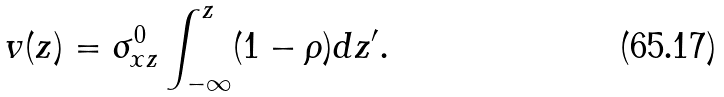<formula> <loc_0><loc_0><loc_500><loc_500>v ( z ) = \sigma _ { x z } ^ { 0 } \int _ { - \infty } ^ { z } ( 1 - \rho ) d z ^ { \prime } .</formula> 